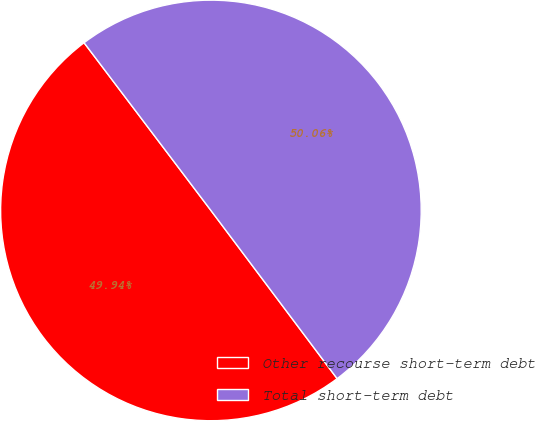<chart> <loc_0><loc_0><loc_500><loc_500><pie_chart><fcel>Other recourse short-term debt<fcel>Total short-term debt<nl><fcel>49.94%<fcel>50.06%<nl></chart> 